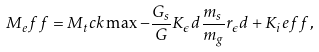Convert formula to latex. <formula><loc_0><loc_0><loc_500><loc_500>M _ { e } f f = M _ { t } c k \max - \frac { G _ { s } } { G } K _ { \epsilon } d \frac { m _ { s } } { m _ { g } } r _ { \epsilon } d + K _ { i } e f f ,</formula> 